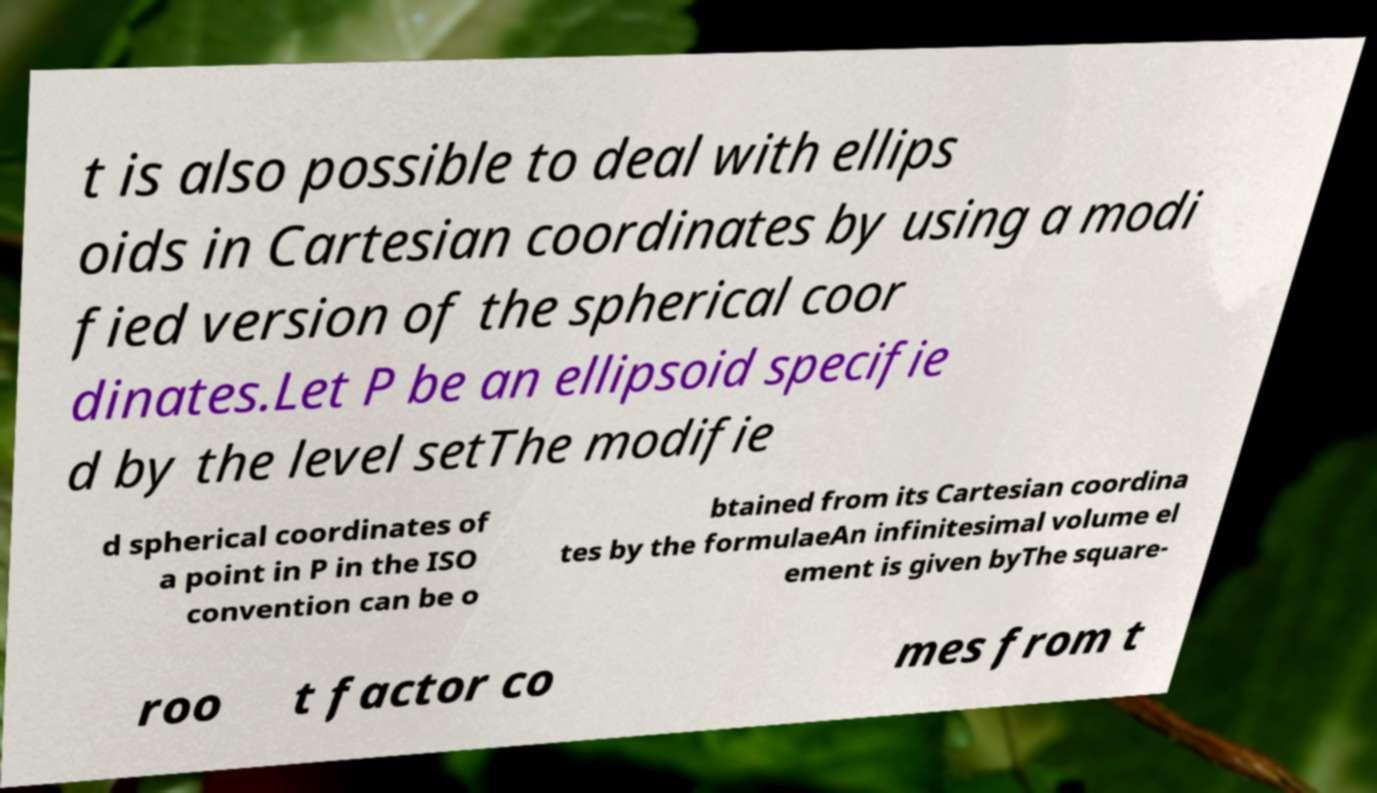Can you read and provide the text displayed in the image?This photo seems to have some interesting text. Can you extract and type it out for me? t is also possible to deal with ellips oids in Cartesian coordinates by using a modi fied version of the spherical coor dinates.Let P be an ellipsoid specifie d by the level setThe modifie d spherical coordinates of a point in P in the ISO convention can be o btained from its Cartesian coordina tes by the formulaeAn infinitesimal volume el ement is given byThe square- roo t factor co mes from t 